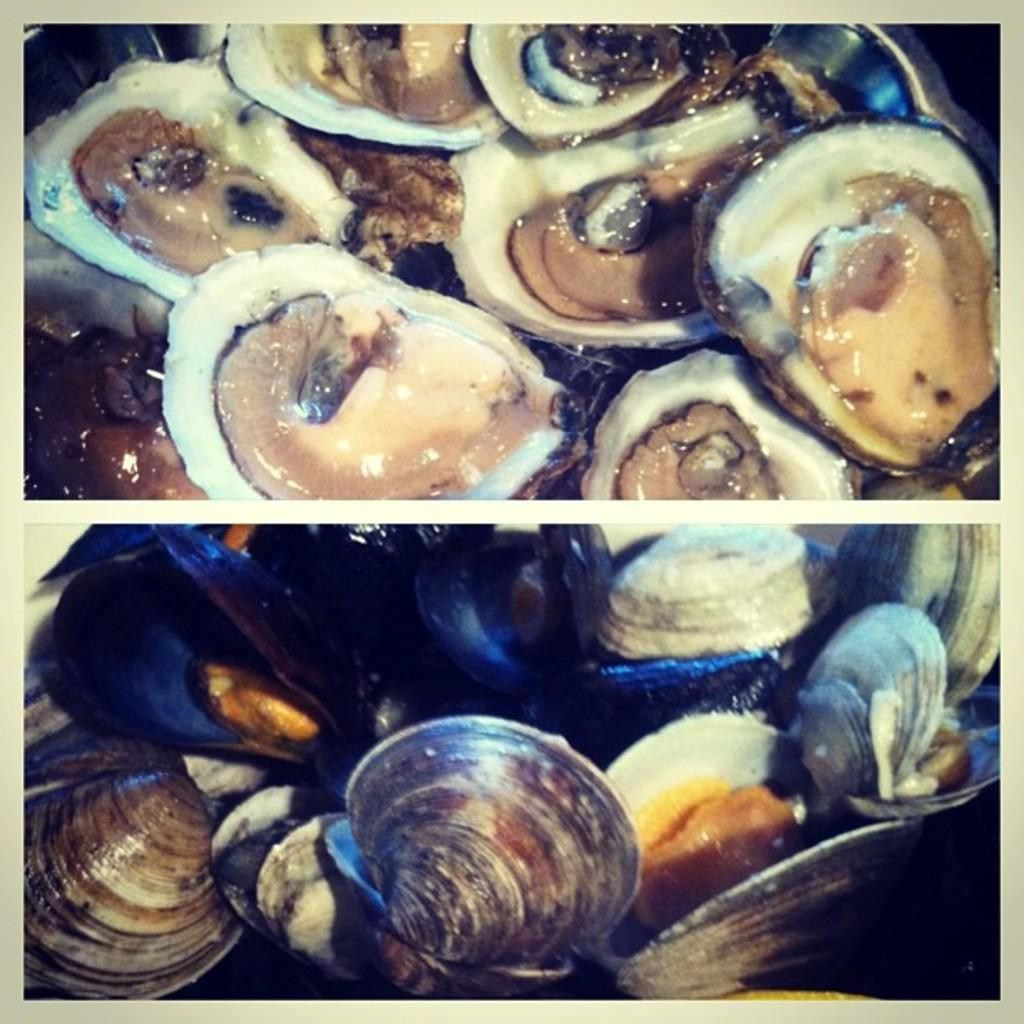What objects are in the bowl that is visible in the image? There are shells in a bowl in the image. How is the image presented? The image is a photo grid. What type of prose can be seen in the image? There is no prose present in the image; it features a bowl of shells and is presented as a photo grid. 